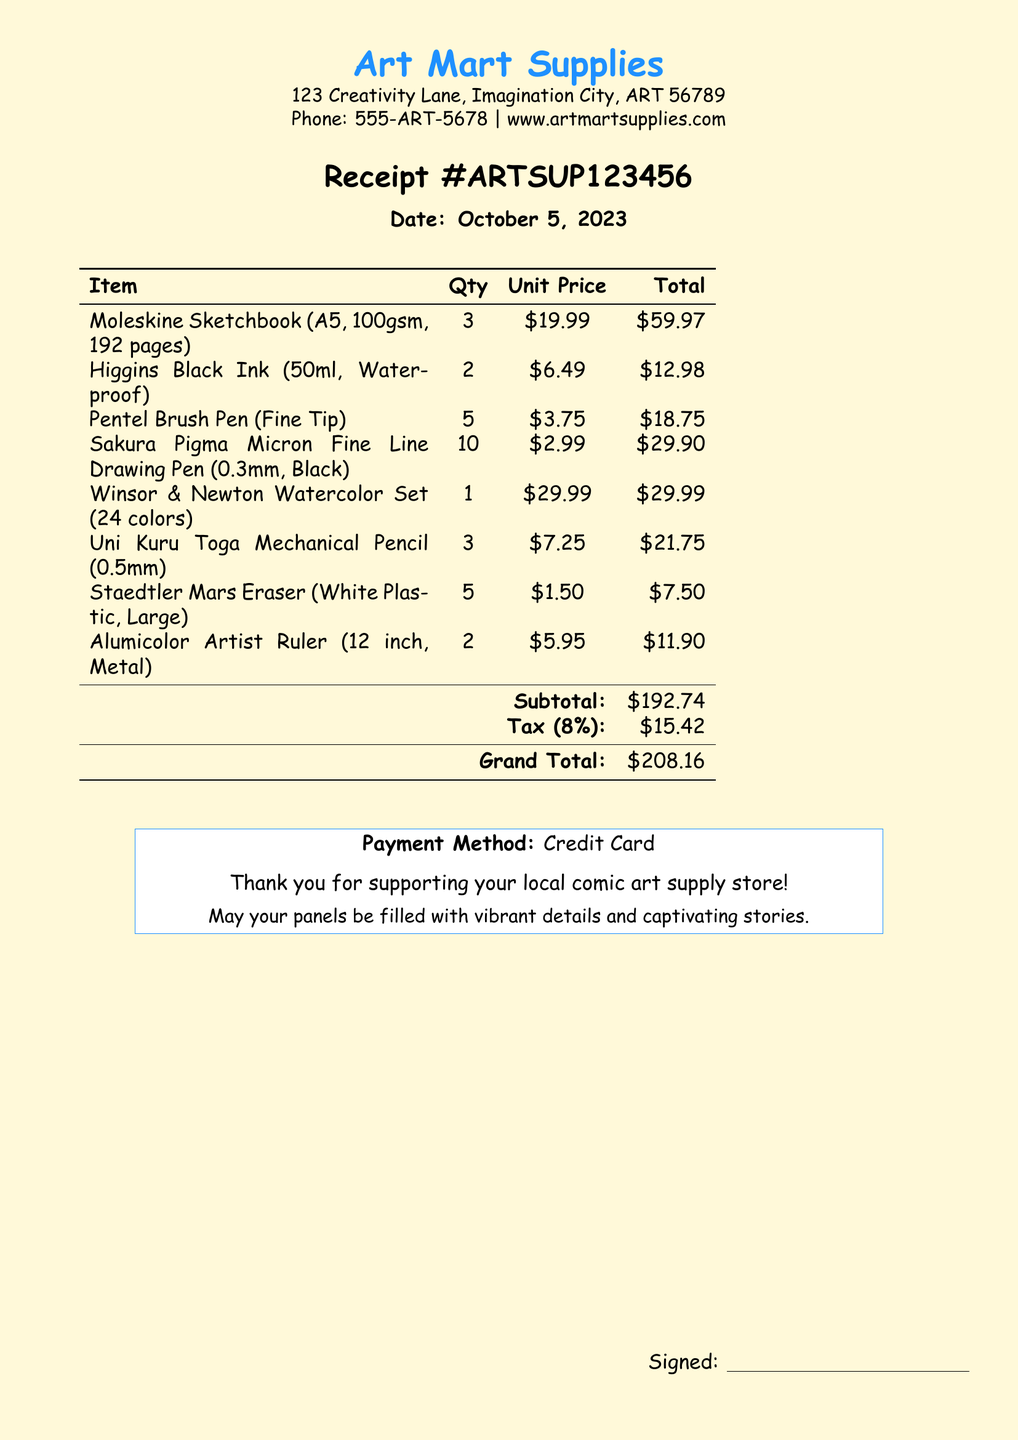What is the date of the receipt? The date of the receipt is specified in the document under the receipt details.
Answer: October 5, 2023 What is the total amount spent? The total amount spent is found in the grand total section of the receipt.
Answer: $208.16 How many Sakura Pigma Micron pens were purchased? The quantity of Sakura Pigma Micron pens is listed in the itemized list.
Answer: 10 What is the unit price of Winsor & Newton Watercolor Set? The unit price of the Winsor & Newton Watercolor Set can be found next to the item in the list.
Answer: $29.99 What type of payment method was used? The payment method is indicated at the bottom of the receipt.
Answer: Credit Card What is the subtotal before tax? The subtotal is calculated as the sum of all items before tax is applied.
Answer: $192.74 Which item had the highest quantity purchased? The item with the highest quantity is identified from the list of purchased items.
Answer: Sakura Pigma Micron Fine Line Drawing Pen What is the tax percentage applied in this receipt? The tax percentage is mentioned in the tax calculation line of the receipt.
Answer: 8% How many Moleskine Sketchbooks were bought? The quantity of Moleskine Sketchbooks is specified in the purchase list of the receipt.
Answer: 3 